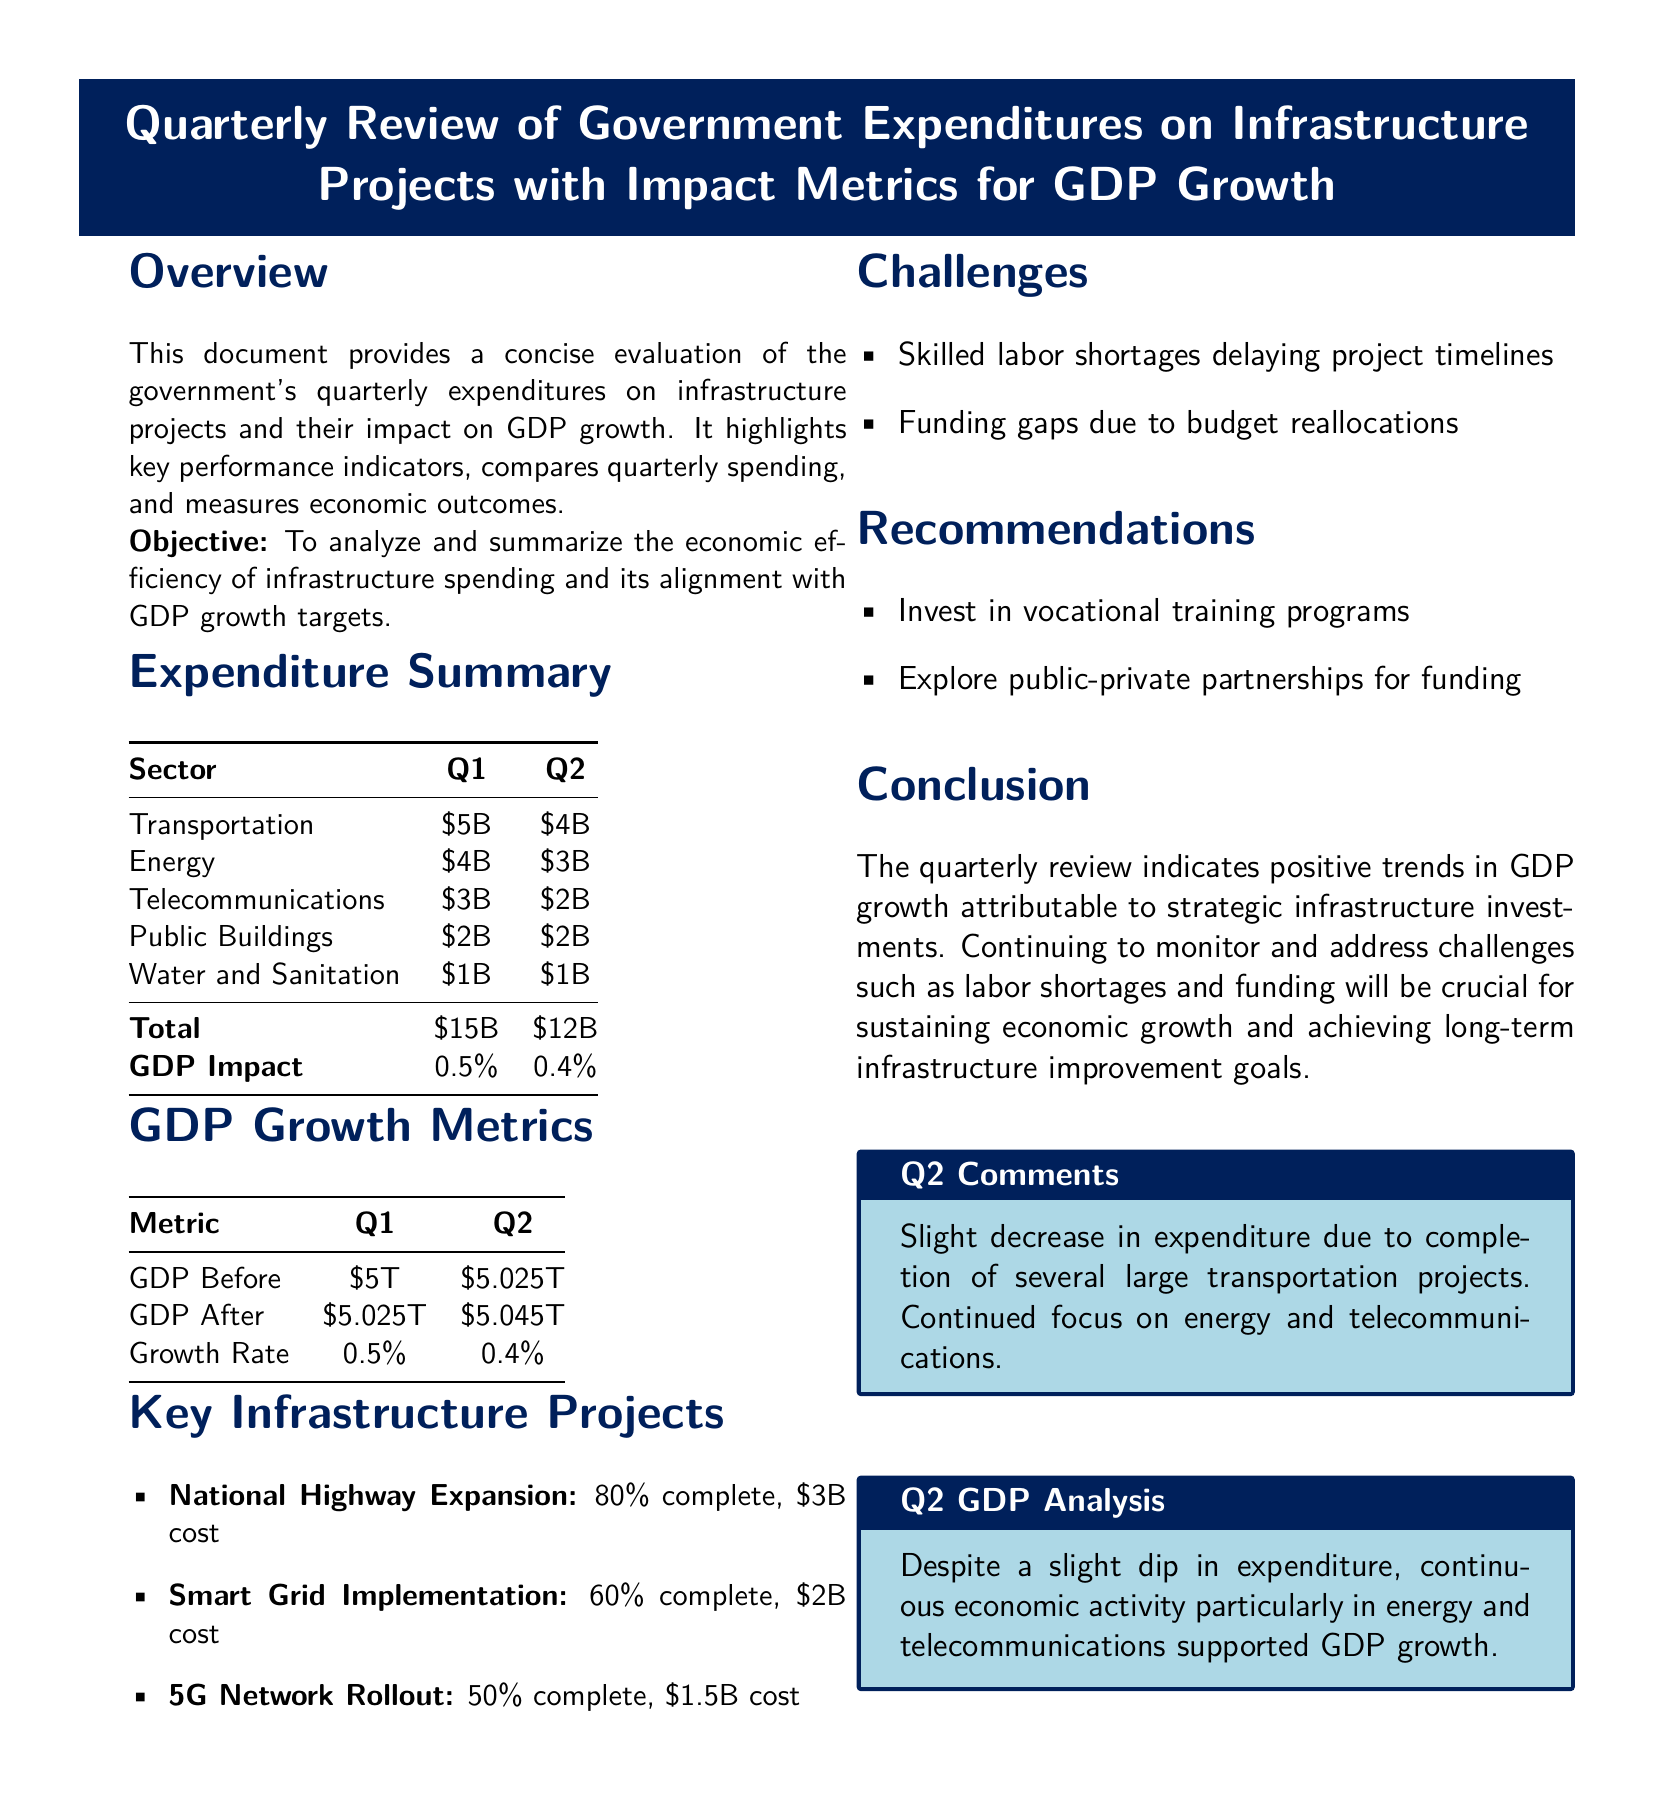what is the total expenditure for Q1? The total expenditure for Q1 is the sum of expenditures across all sectors, which is $5B + $4B + $3B + $2B + $1B = $15B.
Answer: $15B what is the GDP impact for Q2? The GDP impact for Q2 is specified in the expenditure summary table as 0.4%.
Answer: 0.4% which sector had the highest expenditure in Q1? The sector with the highest expenditure in Q1 is Transportation, which had $5B.
Answer: Transportation how many key infrastructure projects are mentioned? The document lists three key infrastructure projects in the key infrastructure projects section.
Answer: 3 what was the GDP growth rate in Q1? The GDP growth rate in Q1 is stated in the GDP growth metrics table as 0.5%.
Answer: 0.5% which challenge is mentioned regarding infrastructure projects? The document mentions skilled labor shortages as one of the challenges affecting infrastructure projects.
Answer: Skilled labor shortages how much was invested in energy projects in Q2? In Q2, the investment in energy projects is listed as $3B in the expenditure summary table.
Answer: $3B what is one recommendation made in the document? The document recommends investing in vocational training programs.
Answer: Invest in vocational training programs 